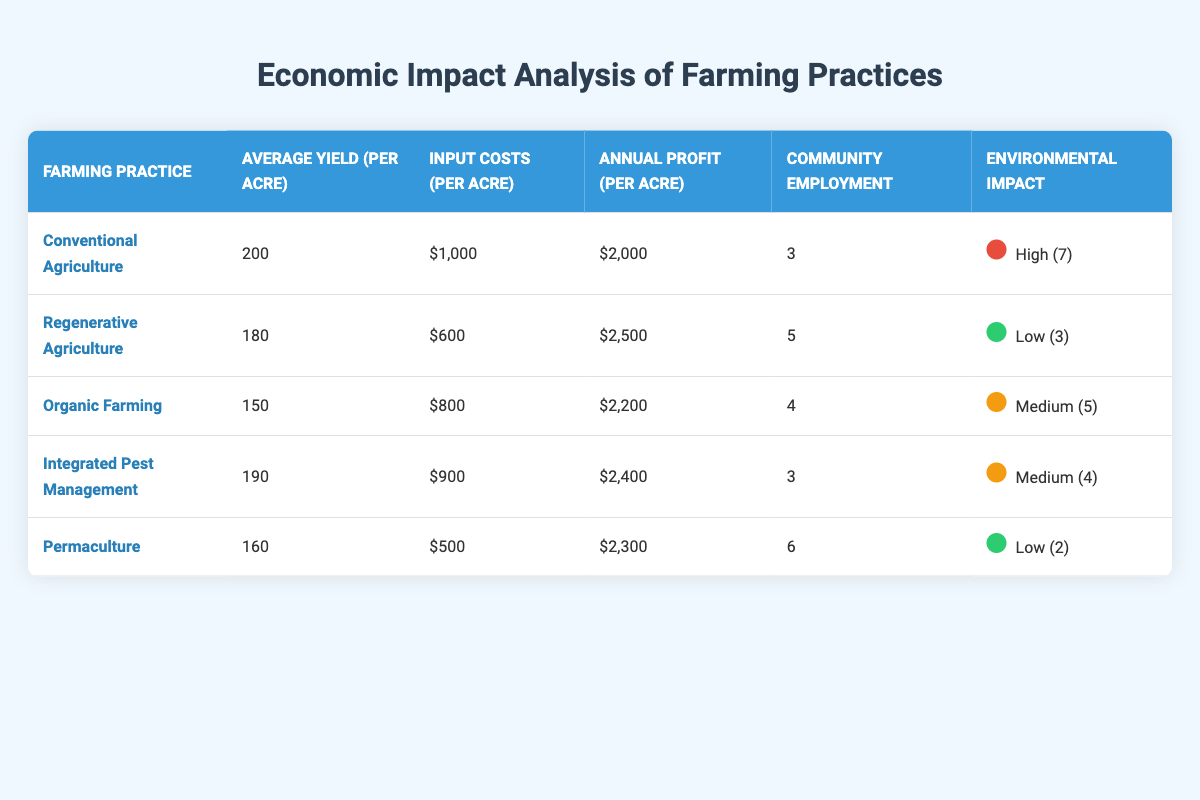What is the average yield per acre for Conventional Agriculture? The table shows that the average yield per acre for Conventional Agriculture is listed as 200.
Answer: 200 Which farming practice has the highest annual profit per acre? According to the table, Regenerative Agriculture has the highest annual profit per acre at 2500.
Answer: 2500 How many acres does Permaculture require for the same annual profit as Integrated Pest Management? The annual profit for Integrated Pest Management is 2400, while Permaculture is 2300. Since both practices vary in profits, let's consider the difference (2400 - 2300 = 100). Therefore, Permaculture will need (100 / (annual profit per acre) = 100 / 2300) ≈ 0.0434 acres to equal the profit of Integrated Pest Management.
Answer: 0.0434 acres Does Organic Farming have a lower input cost per acre compared to Regenerative Agriculture? The table indicates that Organic Farming has an input cost of 800 while Regenerative Agriculture's input cost is 600. Since 800 is greater than 600, the answer is no.
Answer: No If a community employs 3 people per acre in Conventional Agriculture, what would be the total employment for 10 acres? Since Conventional Agriculture has 3 community employment per acre, the calculation for 10 acres would be 3 (employment per acre) multiplied by 10 (acres) = 30.
Answer: 30 What is the difference in average yield between Integrated Pest Management and Permaculture? The average yield for Integrated Pest Management is 190 and for Permaculture it is 160. The difference is calculated by subtracting the two yields (190 - 160 = 30).
Answer: 30 Which farming practice has the lowest environmental impact score? The table indicates that Permaculture has the lowest environmental impact score at 2.
Answer: 2 What would be the total input costs for 5 acres of Organic Farming? The input cost per acre for Organic Farming is 800. To find the total for 5 acres, multiply the cost per acre by the number of acres: 800 * 5 = 4000.
Answer: 4000 How does the average annual profit of Regenerative Agriculture compare to that of Organic Farming? Regenerative Agriculture has an annual profit of 2500, while Organic Farming has 2200. The difference is (2500 - 2200 = 300), which shows Regenerative Agriculture has a higher profit by 300.
Answer: 300 